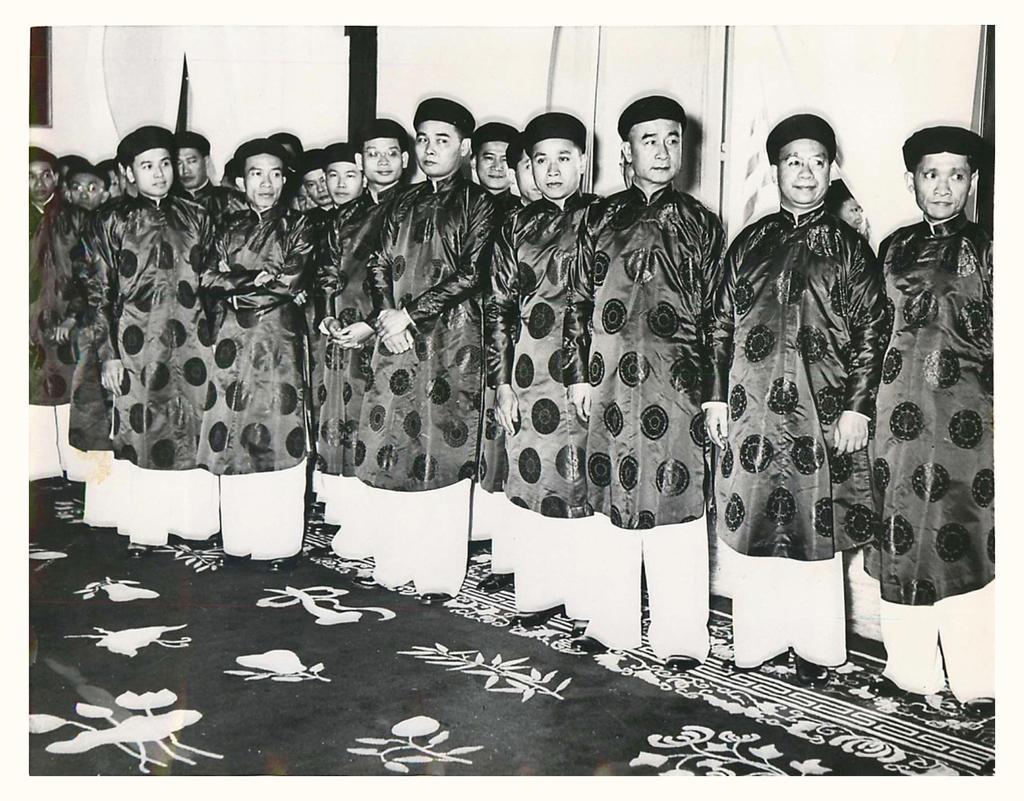Please provide a concise description of this image. In this image I can see the group of people with different color dresses and caps. In the background I can see the frame to the wall and this is a black and white image. 